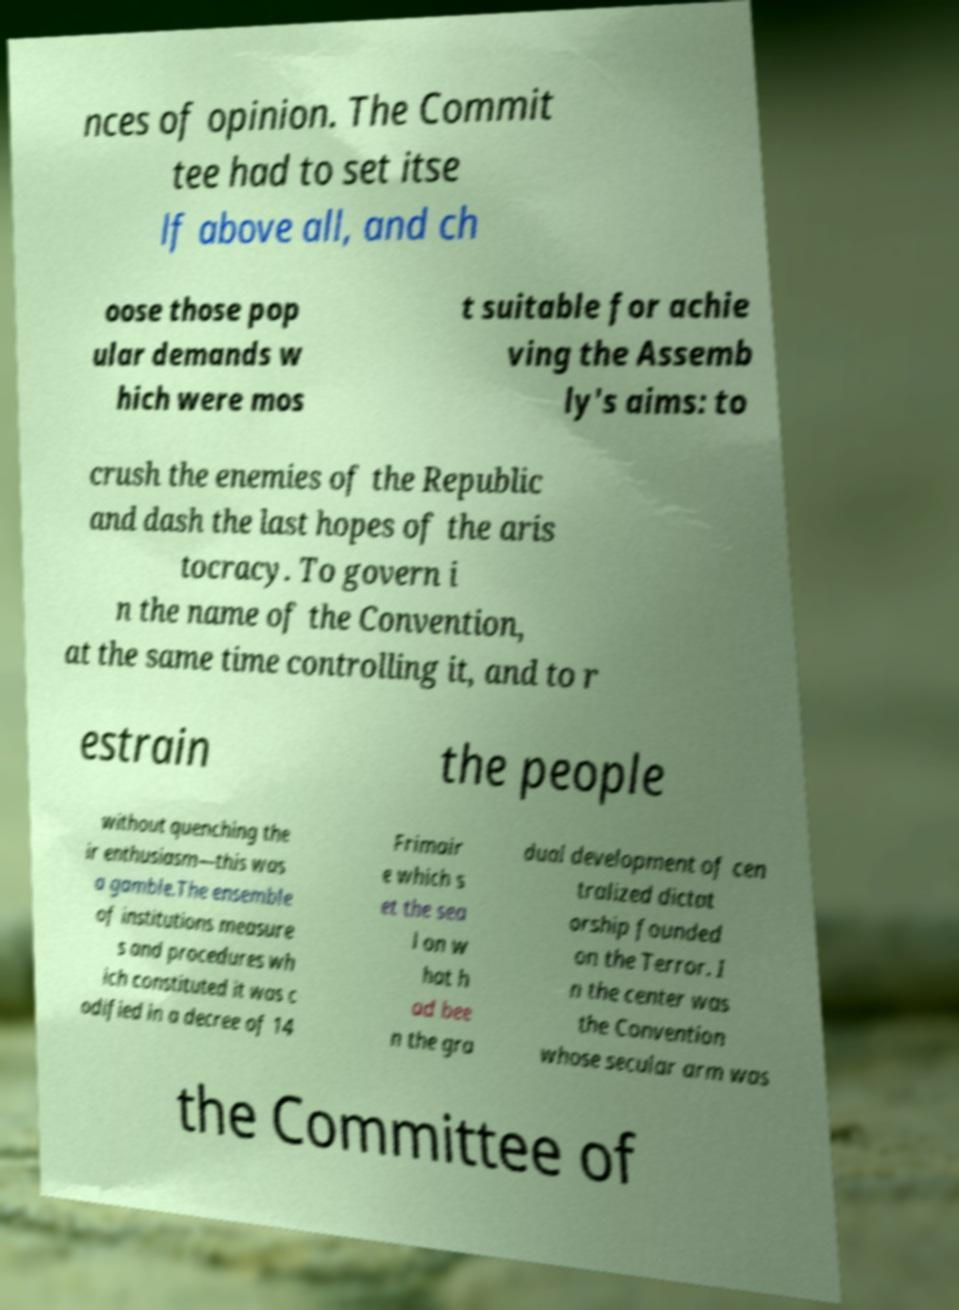What messages or text are displayed in this image? I need them in a readable, typed format. nces of opinion. The Commit tee had to set itse lf above all, and ch oose those pop ular demands w hich were mos t suitable for achie ving the Assemb ly's aims: to crush the enemies of the Republic and dash the last hopes of the aris tocracy. To govern i n the name of the Convention, at the same time controlling it, and to r estrain the people without quenching the ir enthusiasm—this was a gamble.The ensemble of institutions measure s and procedures wh ich constituted it was c odified in a decree of 14 Frimair e which s et the sea l on w hat h ad bee n the gra dual development of cen tralized dictat orship founded on the Terror. I n the center was the Convention whose secular arm was the Committee of 